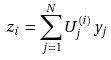Convert formula to latex. <formula><loc_0><loc_0><loc_500><loc_500>z _ { i } \, = \, \sum _ { j = 1 } ^ { N } U _ { j } ^ { ( i ) } \, y _ { j }</formula> 